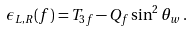<formula> <loc_0><loc_0><loc_500><loc_500>\epsilon _ { L , R } ( f ) = T _ { 3 f } - Q _ { f } \sin ^ { 2 } \theta _ { w } \, .</formula> 